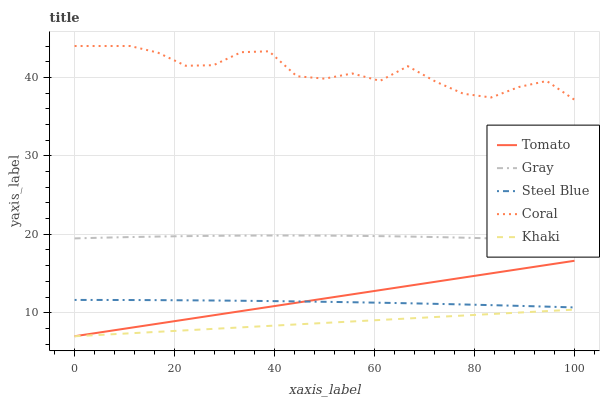Does Khaki have the minimum area under the curve?
Answer yes or no. Yes. Does Coral have the maximum area under the curve?
Answer yes or no. Yes. Does Gray have the minimum area under the curve?
Answer yes or no. No. Does Gray have the maximum area under the curve?
Answer yes or no. No. Is Tomato the smoothest?
Answer yes or no. Yes. Is Coral the roughest?
Answer yes or no. Yes. Is Gray the smoothest?
Answer yes or no. No. Is Gray the roughest?
Answer yes or no. No. Does Tomato have the lowest value?
Answer yes or no. Yes. Does Gray have the lowest value?
Answer yes or no. No. Does Coral have the highest value?
Answer yes or no. Yes. Does Gray have the highest value?
Answer yes or no. No. Is Gray less than Coral?
Answer yes or no. Yes. Is Gray greater than Steel Blue?
Answer yes or no. Yes. Does Steel Blue intersect Tomato?
Answer yes or no. Yes. Is Steel Blue less than Tomato?
Answer yes or no. No. Is Steel Blue greater than Tomato?
Answer yes or no. No. Does Gray intersect Coral?
Answer yes or no. No. 